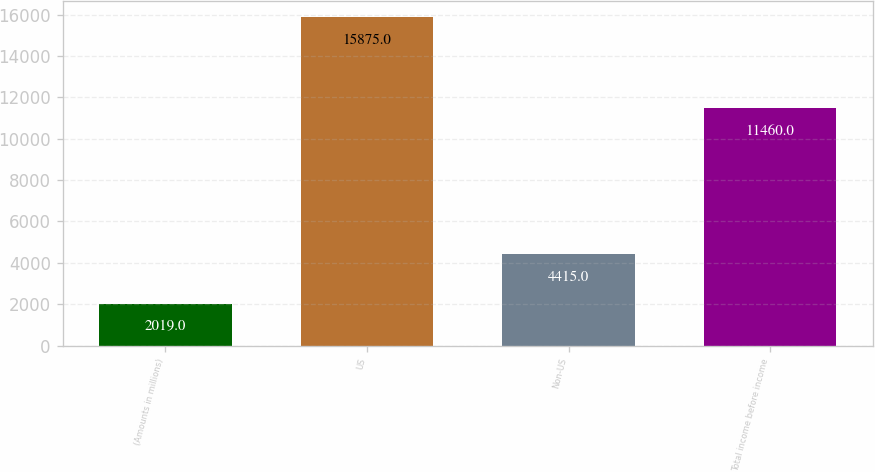Convert chart to OTSL. <chart><loc_0><loc_0><loc_500><loc_500><bar_chart><fcel>(Amounts in millions)<fcel>US<fcel>Non-US<fcel>Total income before income<nl><fcel>2019<fcel>15875<fcel>4415<fcel>11460<nl></chart> 